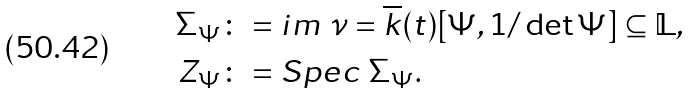Convert formula to latex. <formula><loc_0><loc_0><loc_500><loc_500>\Sigma _ { \Psi } & \colon = i m \ \nu = \overline { k } ( t ) [ \Psi , 1 / \det \Psi ] \subseteq \mathbb { L } , \\ Z _ { \Psi } & \colon = S p e c \ \Sigma _ { \Psi } .</formula> 